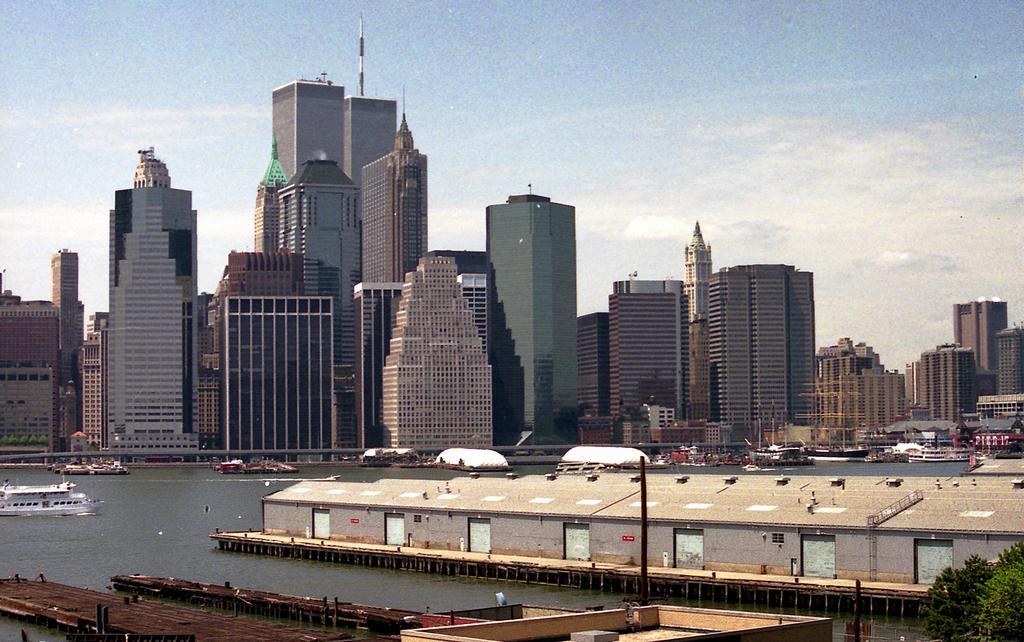How would you summarize this image in a sentence or two? In this image there are tall buildings one beside the other. At the top there is the sky. At the bottom there is water in which there are ships and boats. On the right side there is a bridge in the water in which there is a shed. On the left side there are two wooden bridges in the water. 